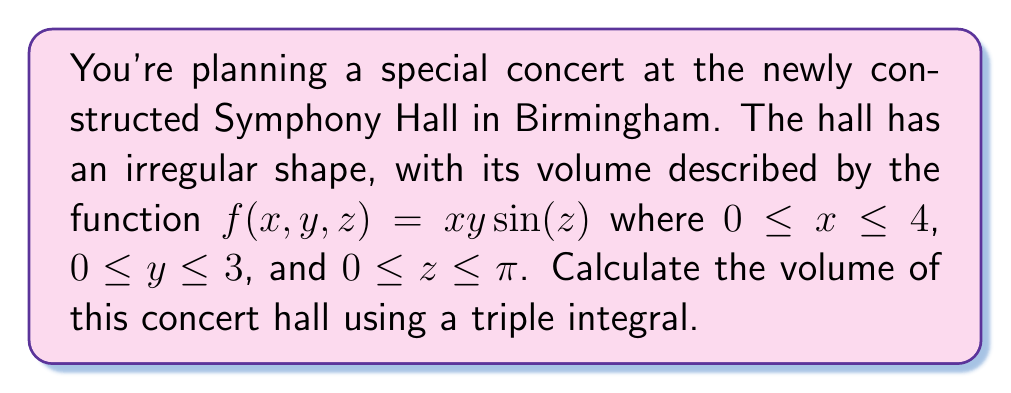Can you answer this question? To find the volume of the irregularly shaped concert hall, we need to set up and evaluate a triple integral. The steps are as follows:

1) The volume is given by the triple integral of the function $f(x,y,z) = xy\sin(z)$ over the given domain.

2) Set up the triple integral:

   $$V = \iiint_V xy\sin(z) \, dV$$

3) Express the integral with the given bounds:

   $$V = \int_0^4 \int_0^3 \int_0^\pi xy\sin(z) \, dz \, dy \, dx$$

4) Evaluate the innermost integral (with respect to z):

   $$V = \int_0^4 \int_0^3 xy \left[-\cos(z)\right]_0^\pi \, dy \, dx$$
   $$V = \int_0^4 \int_0^3 xy \left[-\cos(\pi) - (-\cos(0))\right] \, dy \, dx$$
   $$V = \int_0^4 \int_0^3 xy \left[1 + 1\right] \, dy \, dx$$
   $$V = \int_0^4 \int_0^3 2xy \, dy \, dx$$

5) Evaluate the integral with respect to y:

   $$V = \int_0^4 \left[xy^2\right]_0^3 \, dx$$
   $$V = \int_0^4 (3x^2) \, dx$$

6) Finally, evaluate the integral with respect to x:

   $$V = \left[x^3\right]_0^4$$
   $$V = 4^3 - 0^3 = 64$$

Therefore, the volume of the concert hall is 64 cubic units.
Answer: 64 cubic units 